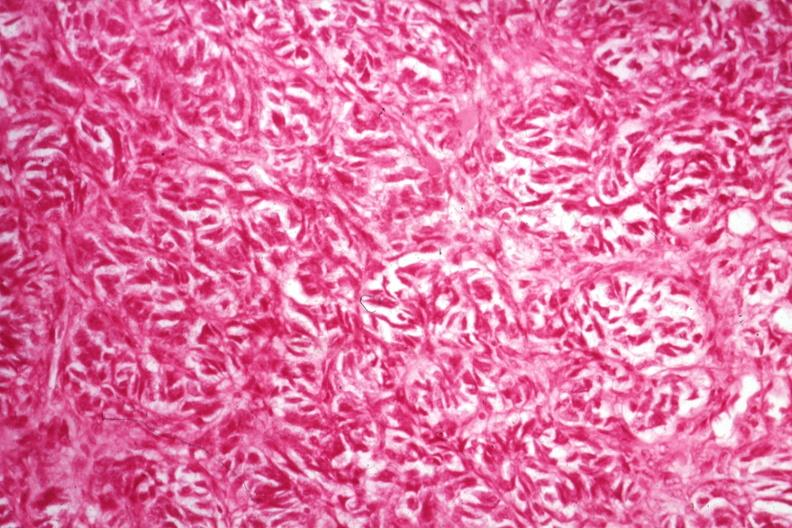where is this from?
Answer the question using a single word or phrase. Female reproductive system 